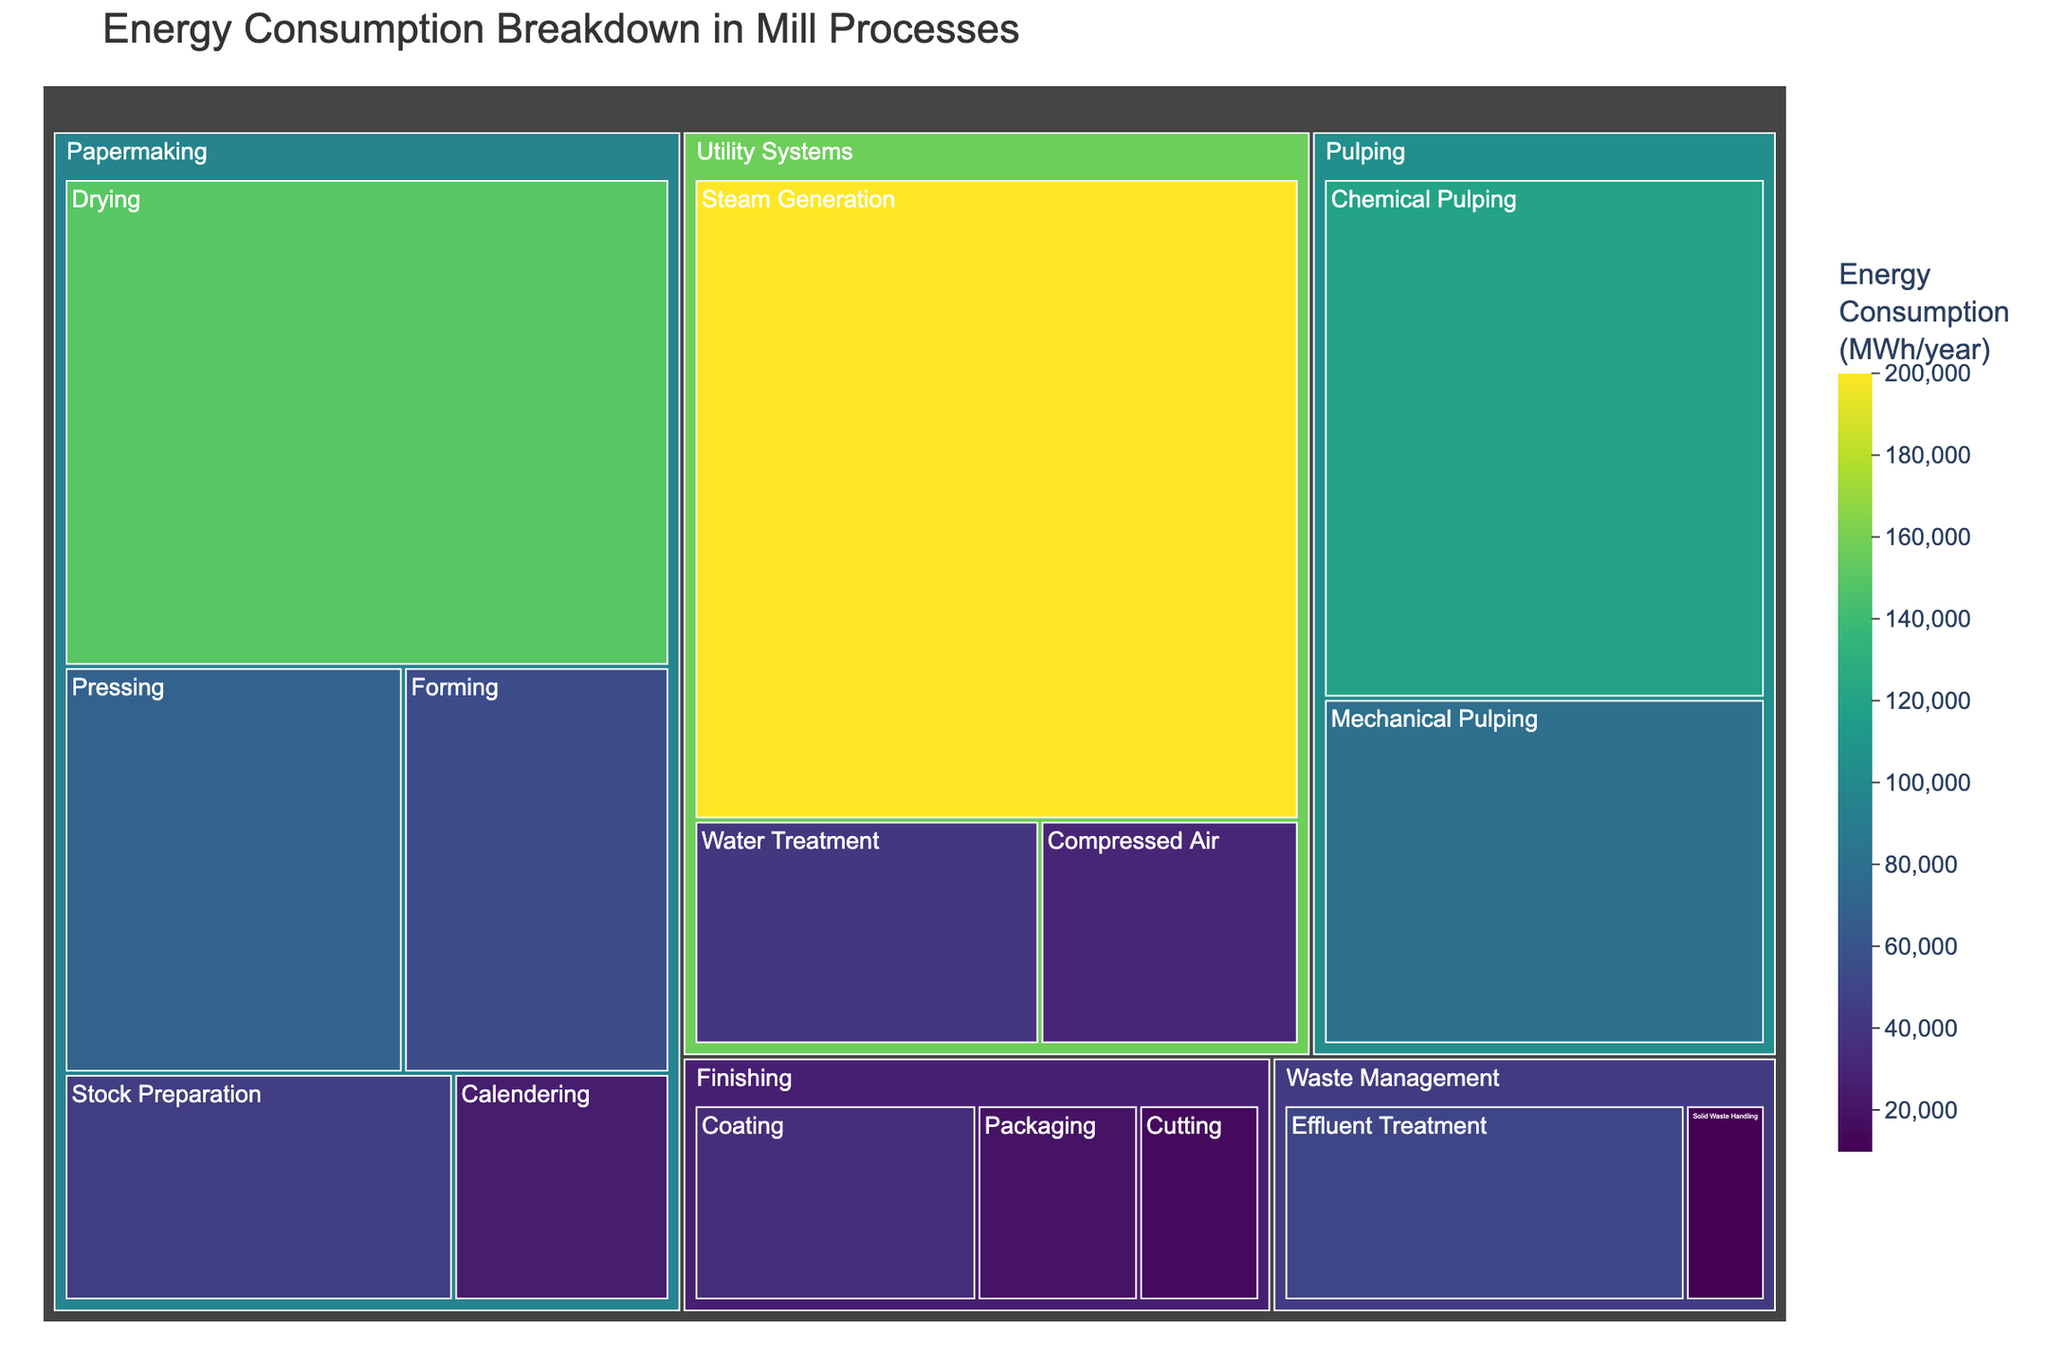What is the title of the treemap? The title is displayed prominently at the top of the treemap. Simply read the text to identify the title.
Answer: Energy Consumption Breakdown in Mill Processes Which subprocess of Utility Systems consumes the most energy? The treemap divides energy consumption by subprocesses under each main process, and the size of the boxes represents the energy consumption. Locate the largest box under Utility Systems.
Answer: Steam Generation How much more energy does Drying consume compared to all processes in the Finishing category combined? First, find the energy consumption for Drying. Then, sum up the energy consumptions for Coating, Cutting, and Packaging under Finishing. Finally, subtract the total of Finishing processes from Drying's energy consumption.
Answer: 80,000 MWh/year more Which subprocess in Papermaking consumes the least energy? Identify the subprocess within Papermaking that has the smallest box, indicating the least energy consumption.
Answer: Calendering Compare the energy consumption of Chemical Pulping to Pressing. Which one consumes more and by how much? Identify the boxes for Chemical Pulping and Pressing. Note their energy consumptions and calculate the difference by subtracting the smaller value from the larger one.
Answer: Chemical Pulping by 50,000 MWh/year What is the total energy consumption for the Waste Management process? Find the subprocesses under Waste Management. Sum their energy consumptions to get the total energy consumption.
Answer: 60,000 MWh/year What percentage of the total energy consumption is used by Steam Generation? Find the energy consumption for Steam Generation and the total energy consumption for all processes. Divide Steam Generation’s consumption by the total and multiply by 100 to get the percentage.
Answer: 22.2% Which main process has the highest variety of subprocesses, and how many subprocesses does it have? Count the number of subprocesses listed under each main process and identify the one with the highest count.
Answer: Papermaking with 5 subprocesses Is the energy consumption for Mechanical Pulping greater than that for Stock Preparation? Compare the sizes of the boxes for Mechanical Pulping and Stock Preparation; the larger box represents higher energy consumption.
Answer: Yes What is the combined energy consumption of all subprocesses in the Utility Systems process? Locate the subprocesses under Utility Systems. Sum their energy consumptions to find the combined total.
Answer: 270,000 MWh/year 